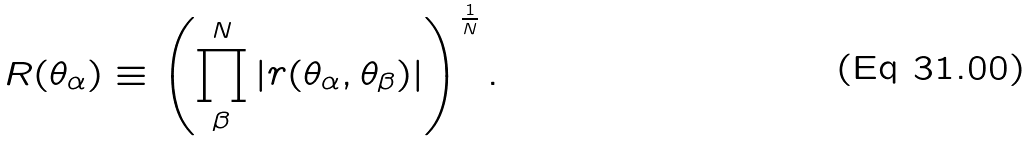<formula> <loc_0><loc_0><loc_500><loc_500>R ( \theta _ { \alpha } ) \equiv \left ( \prod ^ { N } _ { \beta } | r ( \theta _ { \alpha } , \theta _ { \beta } ) | \right ) ^ { \frac { 1 } { N } } .</formula> 